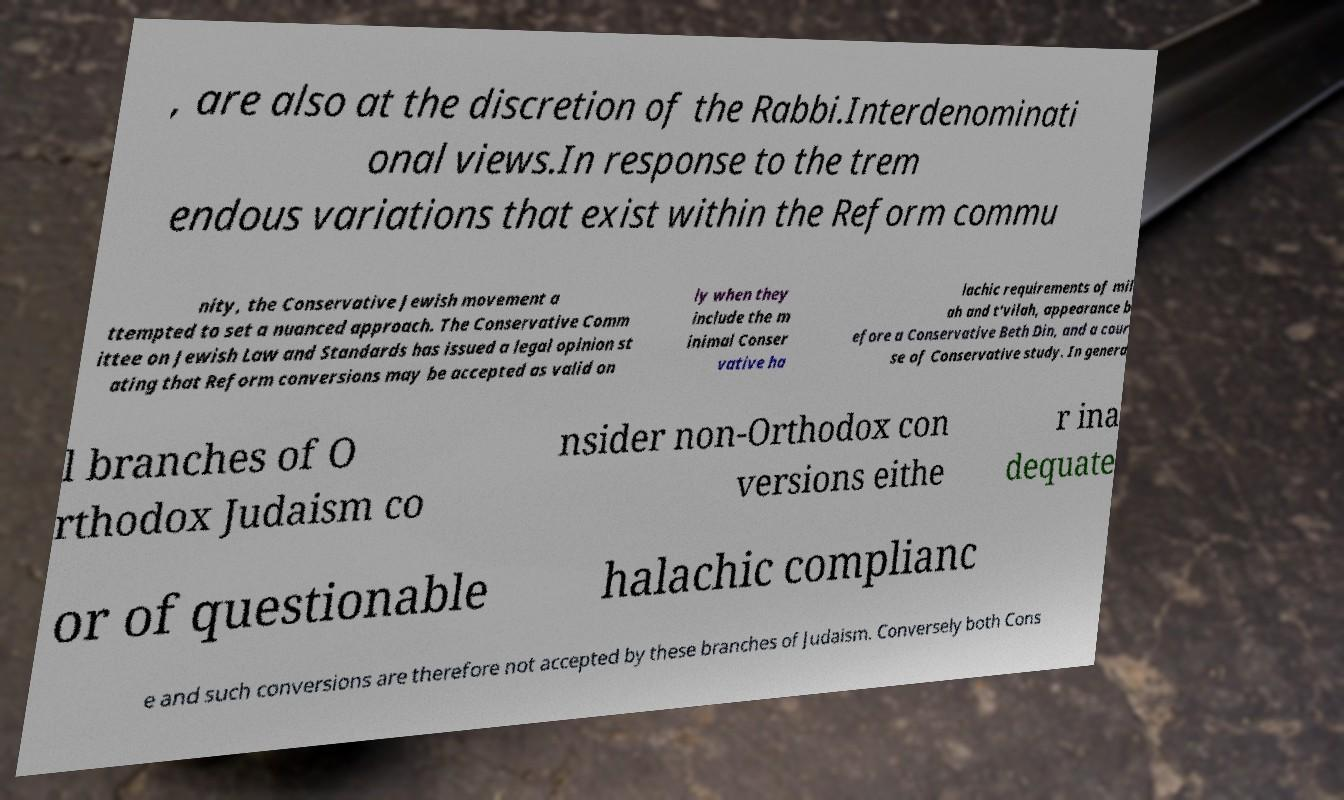For documentation purposes, I need the text within this image transcribed. Could you provide that? , are also at the discretion of the Rabbi.Interdenominati onal views.In response to the trem endous variations that exist within the Reform commu nity, the Conservative Jewish movement a ttempted to set a nuanced approach. The Conservative Comm ittee on Jewish Law and Standards has issued a legal opinion st ating that Reform conversions may be accepted as valid on ly when they include the m inimal Conser vative ha lachic requirements of mil ah and t'vilah, appearance b efore a Conservative Beth Din, and a cour se of Conservative study. In genera l branches of O rthodox Judaism co nsider non-Orthodox con versions eithe r ina dequate or of questionable halachic complianc e and such conversions are therefore not accepted by these branches of Judaism. Conversely both Cons 